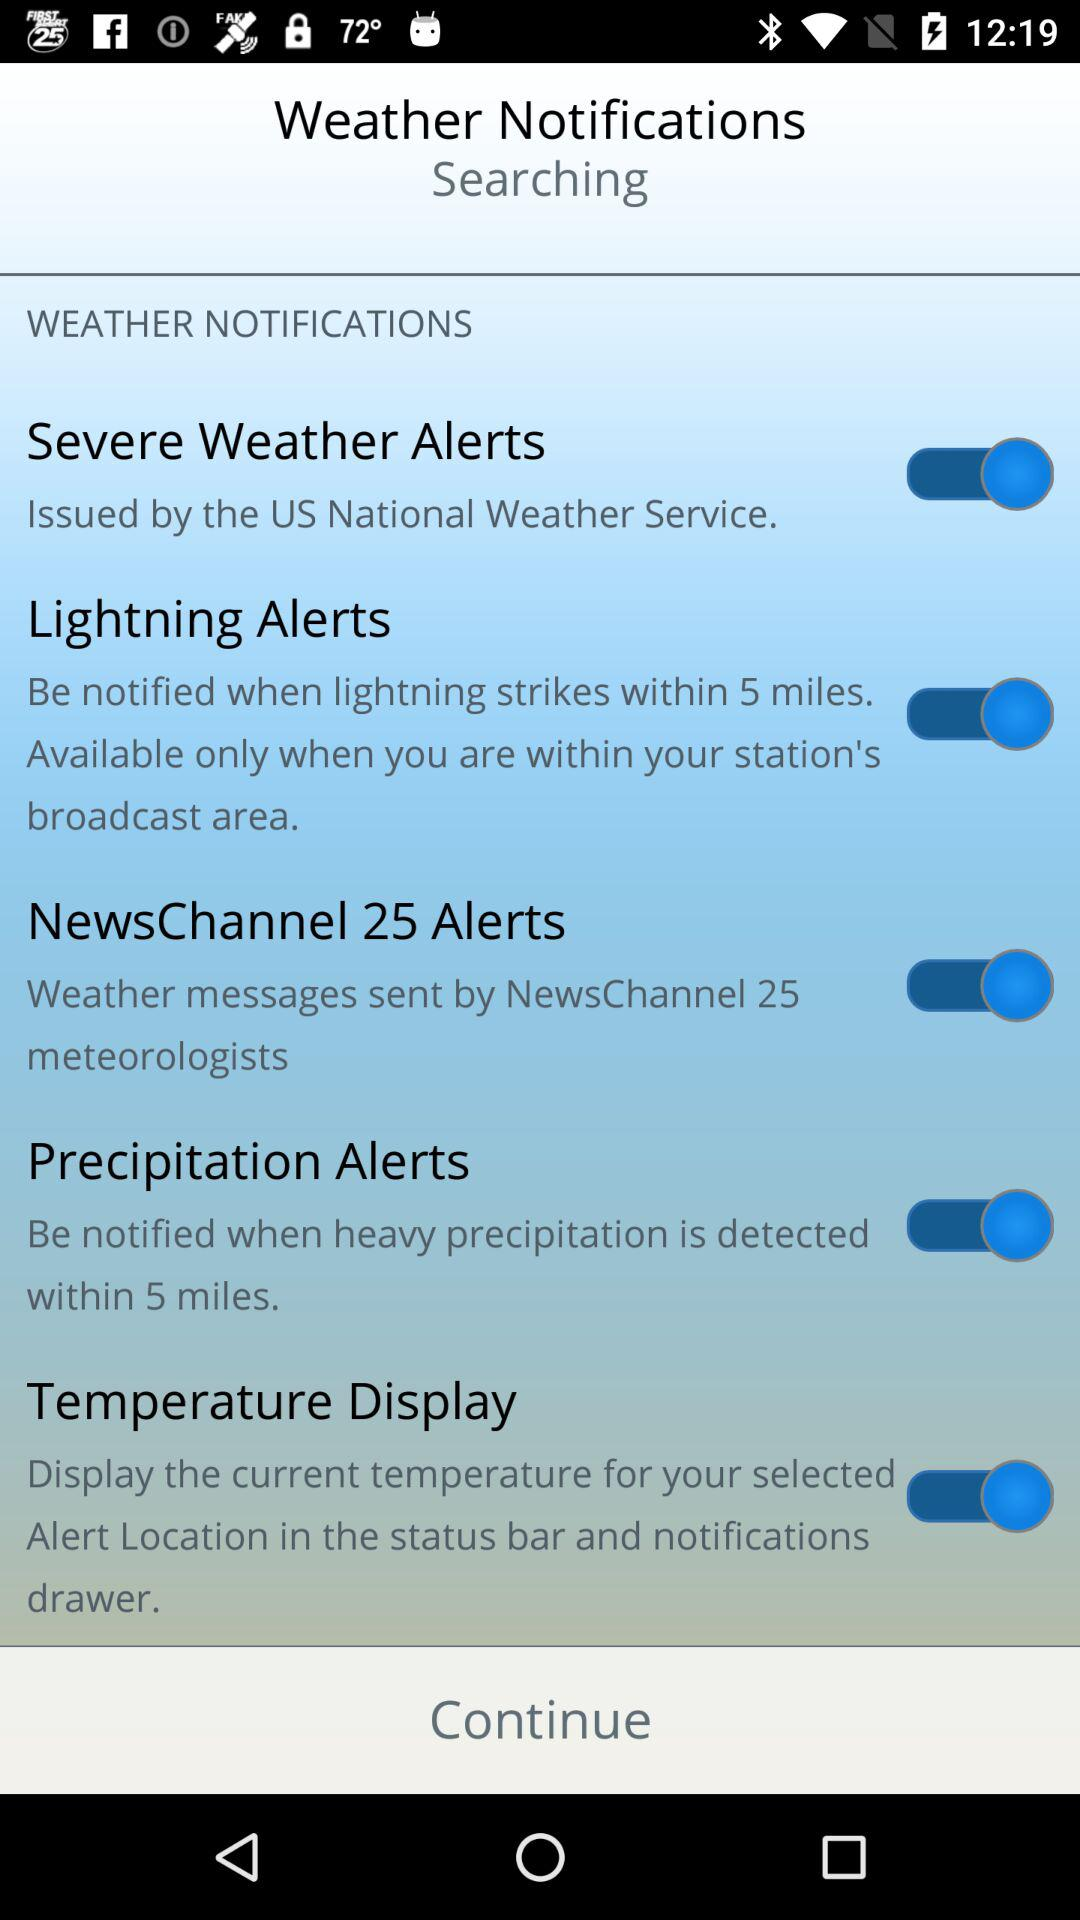What National Weather Service issued the Severe Weather Alerts? Severe Weather Alerts are issued by the US National Weather Service. 